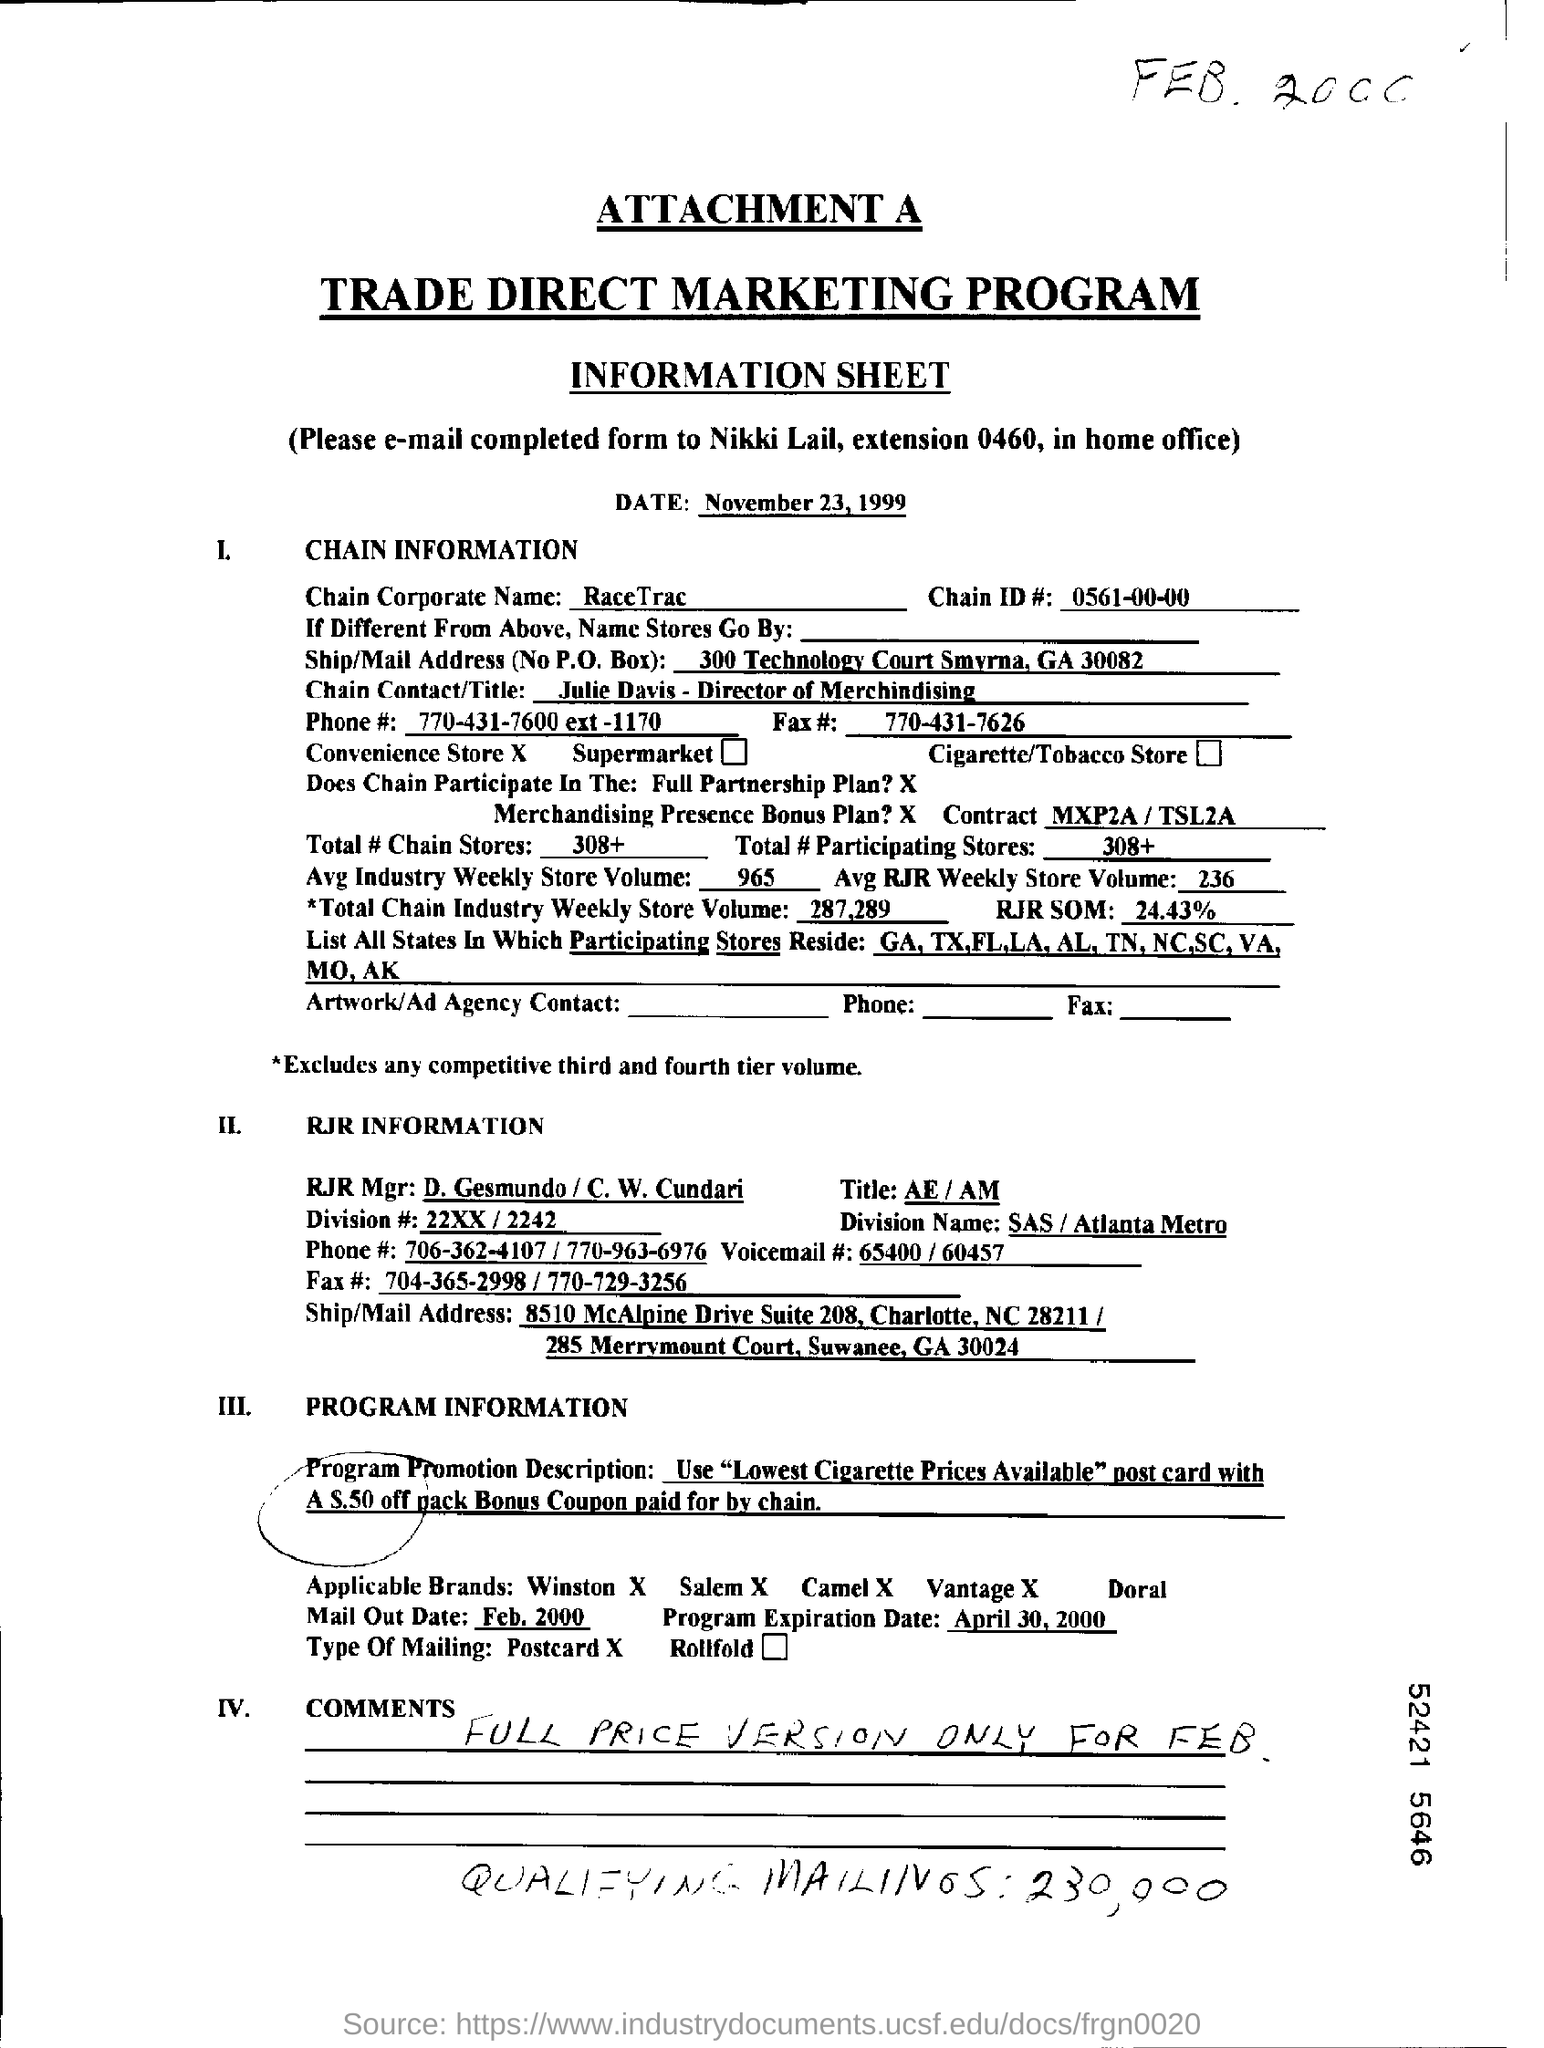Draw attention to some important aspects in this diagram. RaceTrac is the corporate name of the company that operates under the name Chain X. Julie Davis is the chain contact/title. The information sheet is dated November 23, 1999. The completed form should be e-mailed to Nikki Lail. The total number of Chain stores is 308 and continues to increase. 